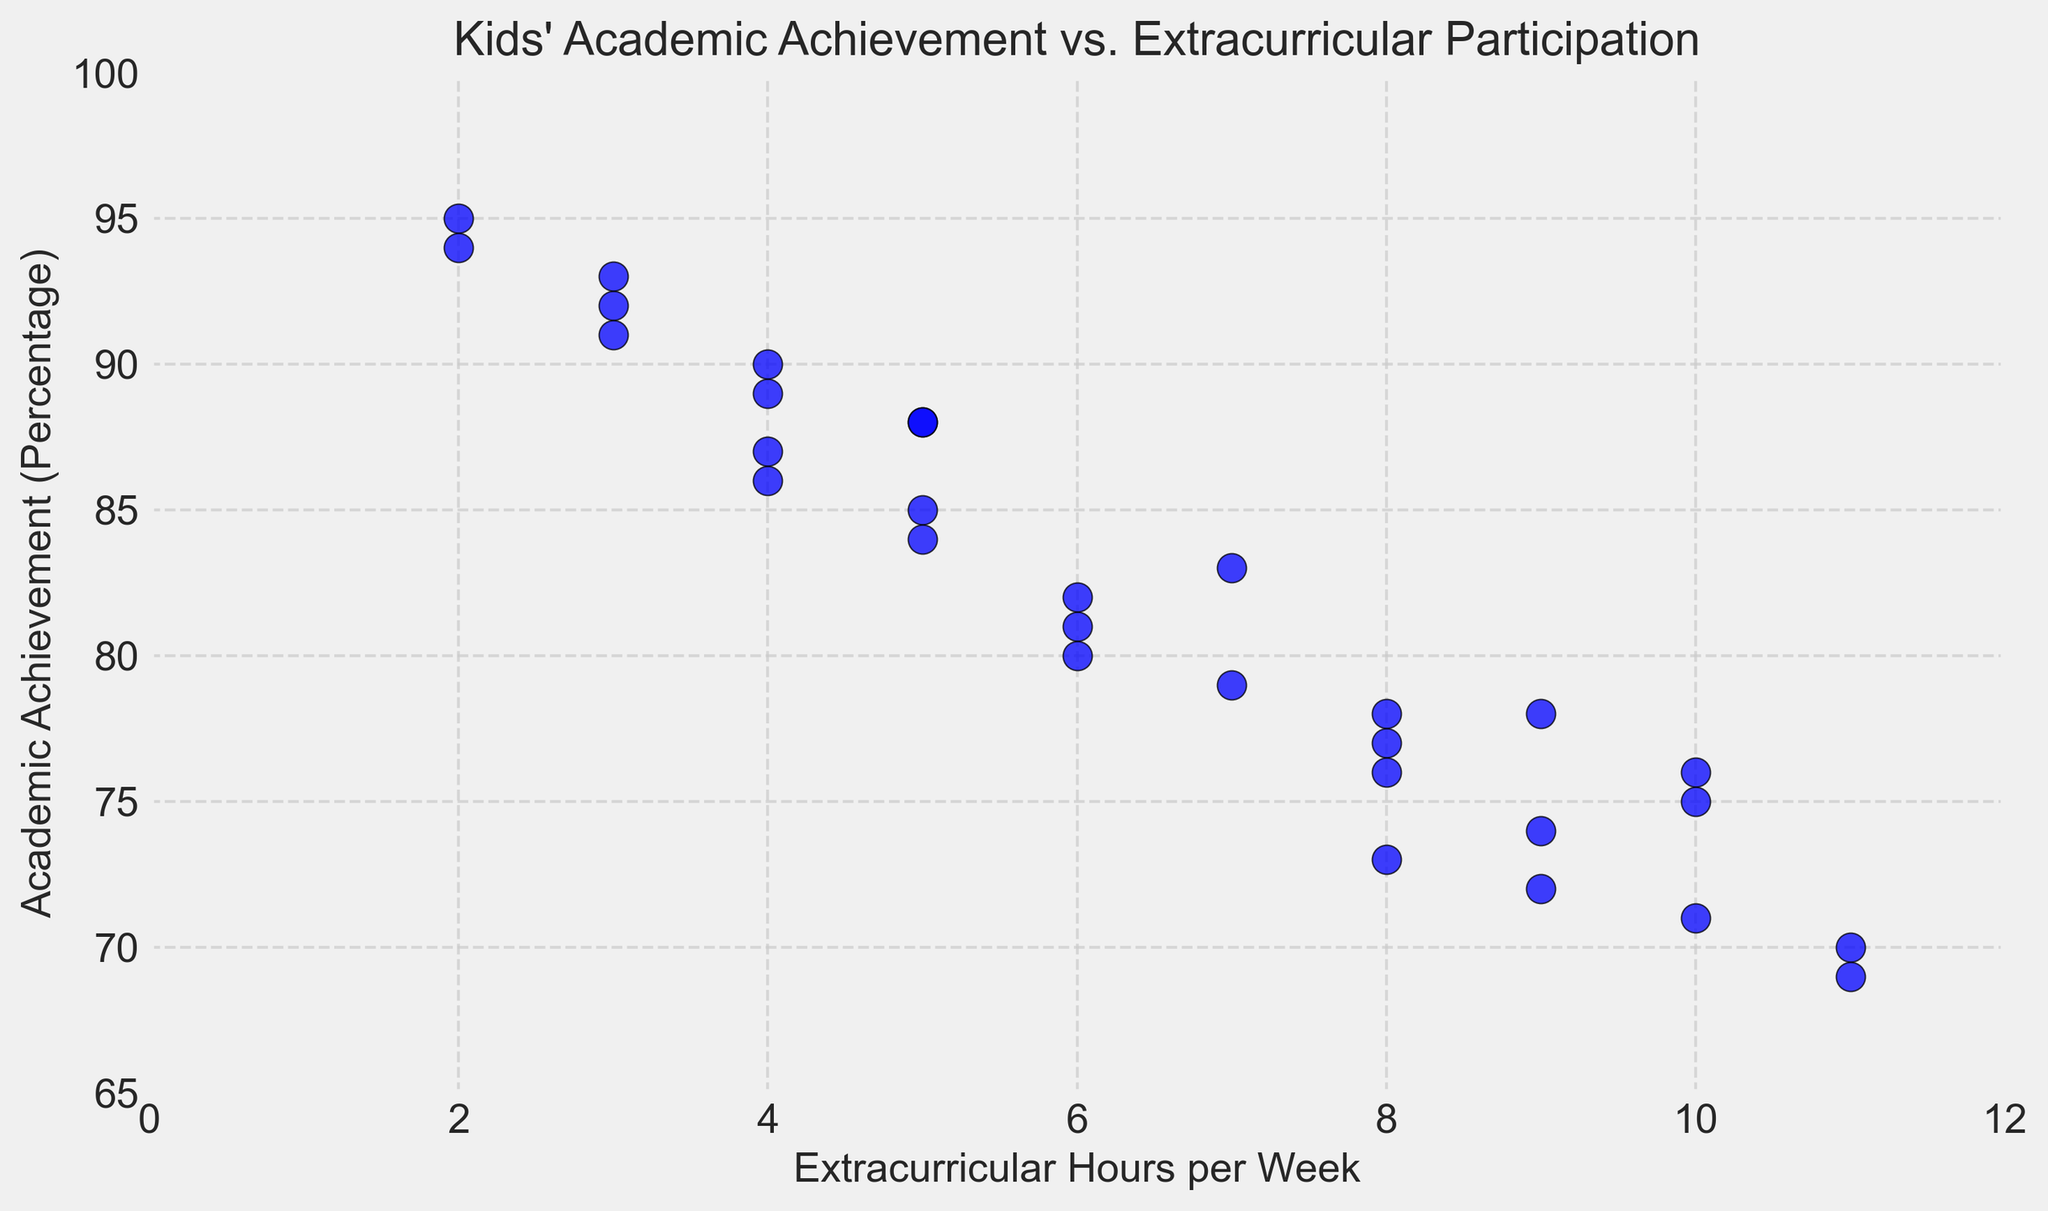What is the title of the scatter plot? The title of the scatter plot is located at the top center of the figure. It reads "Kids' Academic Achievement vs. Extracurricular Participation."
Answer: Kids' Academic Achievement vs. Extracurricular Participation How many extracurricular hours does the student with the highest academic achievement have? To find the student with the highest academic achievement, look for the highest point on the y-axis. The corresponding x-coordinate gives their extracurricular hours. The highest academic achievement is 95%, and the student spends 2 hours on extracurricular activities.
Answer: 2 hours What is the average academic achievement for students participating 8 hours in extracurricular activities? There are three students with 8 extracurricular hours. Their academic achievements are 78, 77, and 76. To find the average, sum these values (78 + 77 + 76 = 231) and divide by 3. So, the average is 231 / 3.
Answer: 77 Which range of extracurricular hours has the most students? Identify the most densely populated area along the x-axis. Positions with the most dots give the range with the most students. Here, the range 4-5 hours appears densest, having six students.
Answer: 4-5 hours How many students have an academic achievement of at least 90%? Count the number of points above the 90% mark on the y-axis. The points at 92, 91, 95, 90, 93, 91, 94, and 90 represent students achieving 90% or more. There are eight such students.
Answer: 8 Is there any student participating 11 hours in extracurricular activities? What is their academic achievement? Look at the x-axis value of 11 and find the corresponding points. There are two students here, with academic achievements of 70% and 69%.
Answer: 70% and 69% What is the relationship between extracurricular hours and academic achievement? Observing the scatter plot, the general trend shows that as extracurricular hours increase, academic achievement tends to decrease. The highest academic achievements are clustered around lower extracurricular hours.
Answer: Typically, more activities lower scores Which student has the lowest academic achievement, and how many extracurricular hours do they participate in? The lowest point on the y-axis represents the student with the lowest academic achievement. The lowest academic achievement is 69%, and this student participates in 11 extracurricular hours.
Answer: 11 hours 